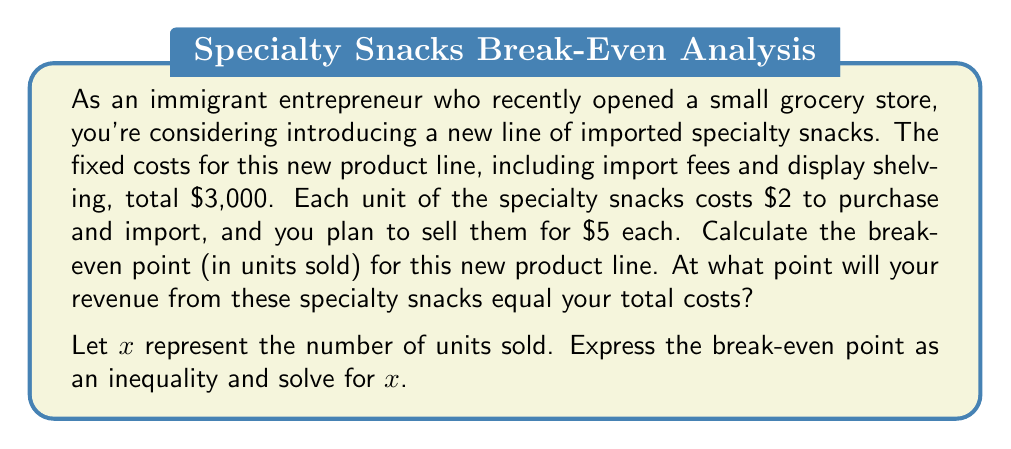Solve this math problem. To solve this problem, we need to use the break-even formula, which is the point where total revenue equals total costs.

Let's define our variables:
- Fixed costs (FC) = $3,000
- Variable cost per unit (VC) = $2
- Selling price per unit (P) = $5
- Number of units sold (x)

The break-even point occurs when:

Total Revenue = Total Costs

We can express this as an equation:

$$ 5x = 3000 + 2x $$

Now, let's solve this equation step by step:

1) Subtract 2x from both sides:
   $$ 3x = 3000 $$

2) Divide both sides by 3:
   $$ x = 1000 $$

Therefore, the break-even point is 1,000 units.

To express this as an inequality for profitability:

Revenue > Total Costs
$$ 5x > 3000 + 2x $$
$$ 3x > 3000 $$
$$ x > 1000 $$

This means you need to sell more than 1,000 units to start making a profit.
Answer: The break-even point is 1,000 units. Expressed as an inequality for profitability: $x > 1000$, where $x$ is the number of units sold. 